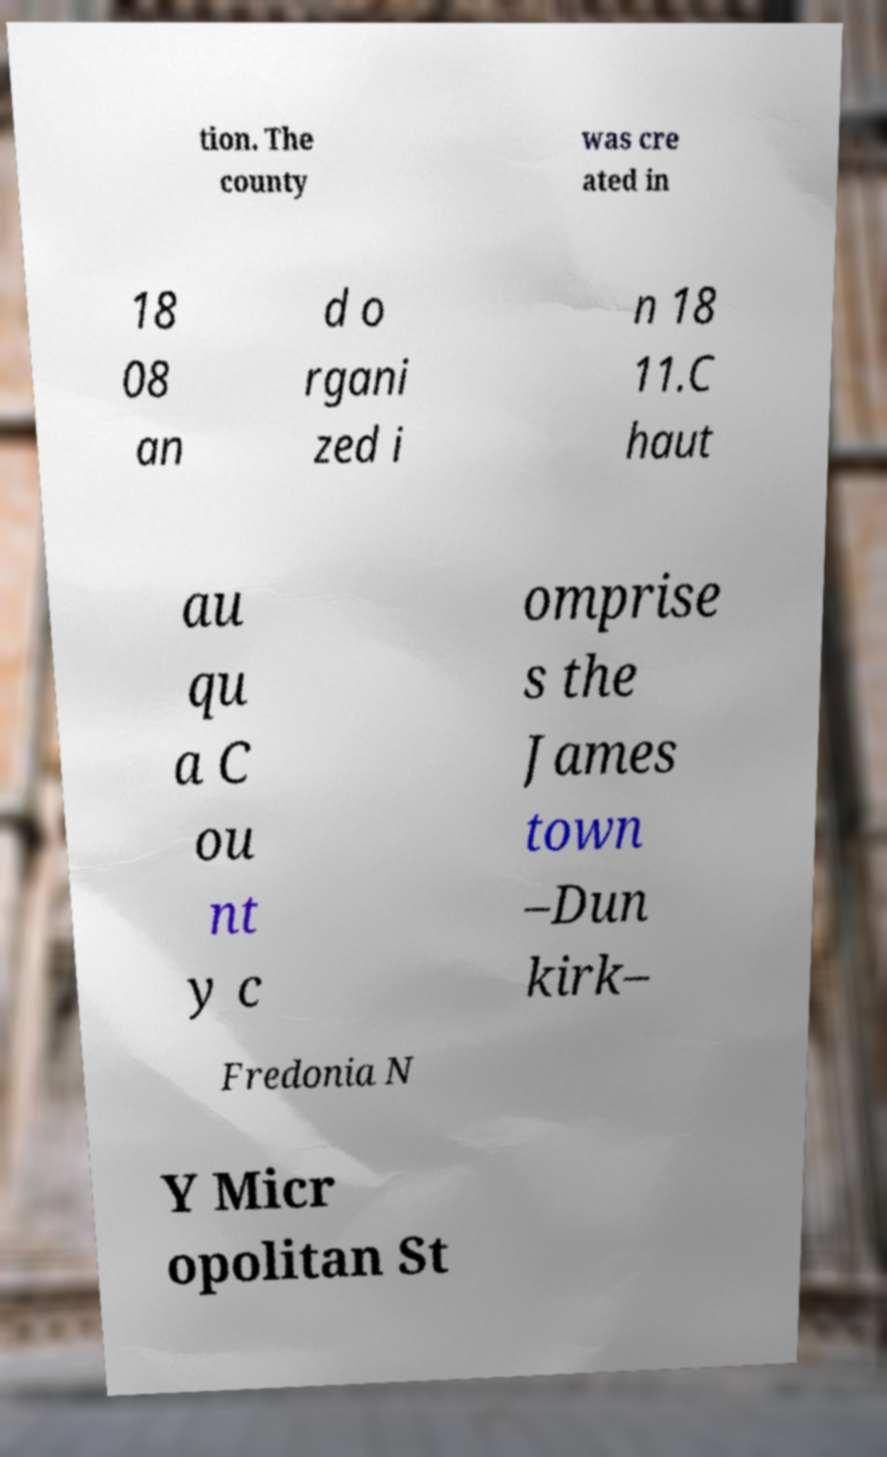What messages or text are displayed in this image? I need them in a readable, typed format. tion. The county was cre ated in 18 08 an d o rgani zed i n 18 11.C haut au qu a C ou nt y c omprise s the James town –Dun kirk– Fredonia N Y Micr opolitan St 